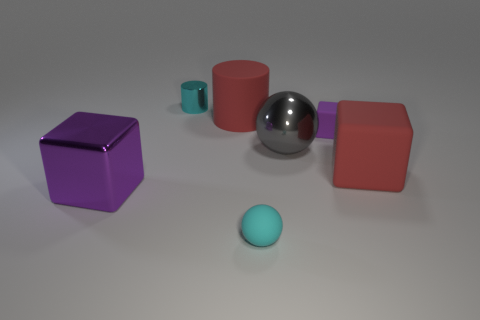Subtract all red spheres. How many purple cubes are left? 2 Add 2 big purple cubes. How many objects exist? 9 Subtract all balls. How many objects are left? 5 Subtract 1 cyan cylinders. How many objects are left? 6 Subtract all metallic things. Subtract all big green metal cylinders. How many objects are left? 4 Add 1 large red matte blocks. How many large red matte blocks are left? 2 Add 4 big shiny cubes. How many big shiny cubes exist? 5 